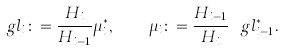Convert formula to latex. <formula><loc_0><loc_0><loc_500><loc_500>\ g l _ { i } \colon = \frac { H _ { i } } { H _ { i - 1 } } \mu ^ { * } _ { i } , \quad \mu _ { i } \colon = \frac { H _ { i - 1 } } { H _ { i } } \ g l ^ { * } _ { i - 1 } .</formula> 